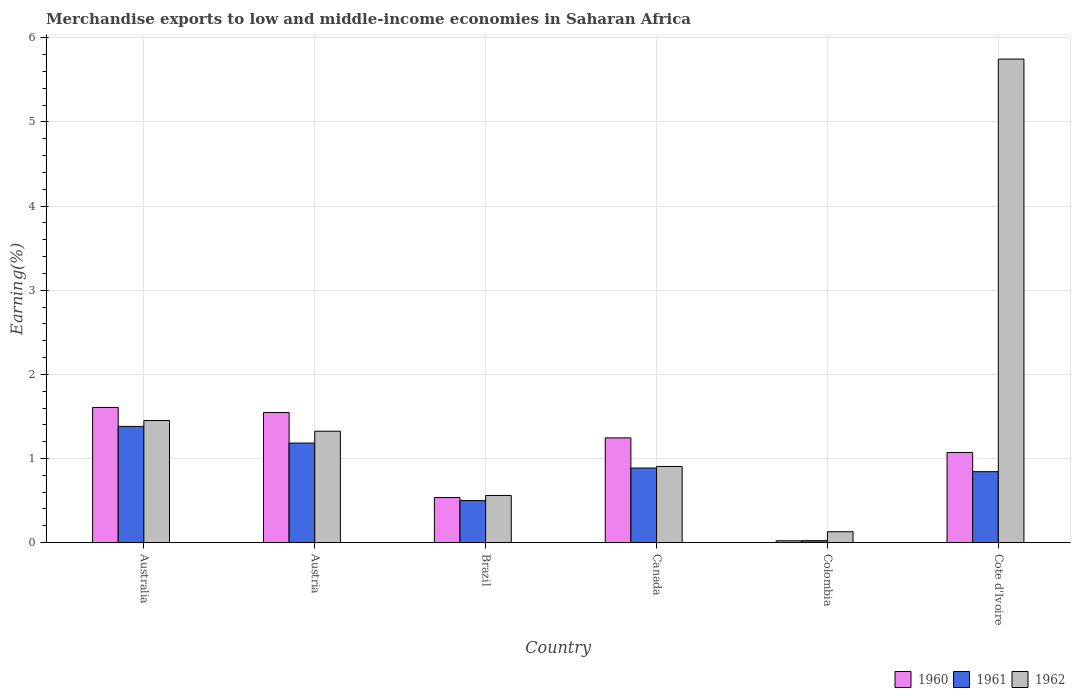How many groups of bars are there?
Give a very brief answer. 6. Are the number of bars on each tick of the X-axis equal?
Offer a terse response. Yes. How many bars are there on the 2nd tick from the left?
Ensure brevity in your answer.  3. What is the label of the 2nd group of bars from the left?
Provide a succinct answer. Austria. What is the percentage of amount earned from merchandise exports in 1961 in Austria?
Your response must be concise. 1.18. Across all countries, what is the maximum percentage of amount earned from merchandise exports in 1962?
Offer a very short reply. 5.75. Across all countries, what is the minimum percentage of amount earned from merchandise exports in 1962?
Give a very brief answer. 0.13. In which country was the percentage of amount earned from merchandise exports in 1962 maximum?
Your answer should be compact. Cote d'Ivoire. In which country was the percentage of amount earned from merchandise exports in 1962 minimum?
Your answer should be compact. Colombia. What is the total percentage of amount earned from merchandise exports in 1962 in the graph?
Your response must be concise. 10.12. What is the difference between the percentage of amount earned from merchandise exports in 1961 in Brazil and that in Colombia?
Give a very brief answer. 0.48. What is the difference between the percentage of amount earned from merchandise exports in 1960 in Canada and the percentage of amount earned from merchandise exports in 1961 in Cote d'Ivoire?
Your response must be concise. 0.4. What is the average percentage of amount earned from merchandise exports in 1961 per country?
Make the answer very short. 0.8. What is the difference between the percentage of amount earned from merchandise exports of/in 1961 and percentage of amount earned from merchandise exports of/in 1960 in Cote d'Ivoire?
Your response must be concise. -0.23. What is the ratio of the percentage of amount earned from merchandise exports in 1962 in Australia to that in Colombia?
Offer a terse response. 11.23. Is the difference between the percentage of amount earned from merchandise exports in 1961 in Australia and Cote d'Ivoire greater than the difference between the percentage of amount earned from merchandise exports in 1960 in Australia and Cote d'Ivoire?
Your answer should be compact. Yes. What is the difference between the highest and the second highest percentage of amount earned from merchandise exports in 1960?
Offer a terse response. 0.36. What is the difference between the highest and the lowest percentage of amount earned from merchandise exports in 1962?
Provide a succinct answer. 5.62. Is it the case that in every country, the sum of the percentage of amount earned from merchandise exports in 1961 and percentage of amount earned from merchandise exports in 1960 is greater than the percentage of amount earned from merchandise exports in 1962?
Your response must be concise. No. How many bars are there?
Provide a short and direct response. 18. Are all the bars in the graph horizontal?
Provide a short and direct response. No. What is the difference between two consecutive major ticks on the Y-axis?
Provide a succinct answer. 1. Does the graph contain any zero values?
Your response must be concise. No. How many legend labels are there?
Offer a terse response. 3. What is the title of the graph?
Give a very brief answer. Merchandise exports to low and middle-income economies in Saharan Africa. Does "1994" appear as one of the legend labels in the graph?
Your answer should be compact. No. What is the label or title of the X-axis?
Your answer should be very brief. Country. What is the label or title of the Y-axis?
Make the answer very short. Earning(%). What is the Earning(%) in 1960 in Australia?
Your answer should be compact. 1.61. What is the Earning(%) in 1961 in Australia?
Keep it short and to the point. 1.38. What is the Earning(%) in 1962 in Australia?
Offer a very short reply. 1.45. What is the Earning(%) in 1960 in Austria?
Your response must be concise. 1.55. What is the Earning(%) of 1961 in Austria?
Offer a terse response. 1.18. What is the Earning(%) of 1962 in Austria?
Make the answer very short. 1.32. What is the Earning(%) of 1960 in Brazil?
Provide a short and direct response. 0.54. What is the Earning(%) of 1961 in Brazil?
Offer a terse response. 0.5. What is the Earning(%) in 1962 in Brazil?
Your answer should be compact. 0.56. What is the Earning(%) of 1960 in Canada?
Provide a succinct answer. 1.24. What is the Earning(%) in 1961 in Canada?
Provide a succinct answer. 0.89. What is the Earning(%) in 1962 in Canada?
Ensure brevity in your answer.  0.9. What is the Earning(%) of 1960 in Colombia?
Your answer should be compact. 0.02. What is the Earning(%) of 1961 in Colombia?
Make the answer very short. 0.02. What is the Earning(%) in 1962 in Colombia?
Keep it short and to the point. 0.13. What is the Earning(%) in 1960 in Cote d'Ivoire?
Provide a short and direct response. 1.07. What is the Earning(%) in 1961 in Cote d'Ivoire?
Ensure brevity in your answer.  0.84. What is the Earning(%) of 1962 in Cote d'Ivoire?
Your answer should be compact. 5.75. Across all countries, what is the maximum Earning(%) in 1960?
Ensure brevity in your answer.  1.61. Across all countries, what is the maximum Earning(%) in 1961?
Provide a short and direct response. 1.38. Across all countries, what is the maximum Earning(%) of 1962?
Ensure brevity in your answer.  5.75. Across all countries, what is the minimum Earning(%) of 1960?
Your response must be concise. 0.02. Across all countries, what is the minimum Earning(%) in 1961?
Your response must be concise. 0.02. Across all countries, what is the minimum Earning(%) in 1962?
Your answer should be very brief. 0.13. What is the total Earning(%) of 1960 in the graph?
Offer a very short reply. 6.03. What is the total Earning(%) of 1961 in the graph?
Keep it short and to the point. 4.82. What is the total Earning(%) of 1962 in the graph?
Make the answer very short. 10.12. What is the difference between the Earning(%) in 1960 in Australia and that in Austria?
Provide a succinct answer. 0.06. What is the difference between the Earning(%) in 1961 in Australia and that in Austria?
Your answer should be very brief. 0.2. What is the difference between the Earning(%) of 1962 in Australia and that in Austria?
Your answer should be compact. 0.13. What is the difference between the Earning(%) of 1960 in Australia and that in Brazil?
Keep it short and to the point. 1.07. What is the difference between the Earning(%) in 1961 in Australia and that in Brazil?
Provide a succinct answer. 0.88. What is the difference between the Earning(%) in 1962 in Australia and that in Brazil?
Your answer should be compact. 0.89. What is the difference between the Earning(%) of 1960 in Australia and that in Canada?
Offer a terse response. 0.36. What is the difference between the Earning(%) in 1961 in Australia and that in Canada?
Ensure brevity in your answer.  0.49. What is the difference between the Earning(%) of 1962 in Australia and that in Canada?
Keep it short and to the point. 0.55. What is the difference between the Earning(%) of 1960 in Australia and that in Colombia?
Your answer should be very brief. 1.59. What is the difference between the Earning(%) in 1961 in Australia and that in Colombia?
Offer a very short reply. 1.36. What is the difference between the Earning(%) in 1962 in Australia and that in Colombia?
Your answer should be very brief. 1.32. What is the difference between the Earning(%) of 1960 in Australia and that in Cote d'Ivoire?
Your answer should be very brief. 0.54. What is the difference between the Earning(%) in 1961 in Australia and that in Cote d'Ivoire?
Provide a succinct answer. 0.54. What is the difference between the Earning(%) in 1962 in Australia and that in Cote d'Ivoire?
Provide a short and direct response. -4.3. What is the difference between the Earning(%) in 1960 in Austria and that in Brazil?
Provide a succinct answer. 1.01. What is the difference between the Earning(%) in 1961 in Austria and that in Brazil?
Keep it short and to the point. 0.68. What is the difference between the Earning(%) of 1962 in Austria and that in Brazil?
Offer a very short reply. 0.76. What is the difference between the Earning(%) in 1960 in Austria and that in Canada?
Offer a terse response. 0.3. What is the difference between the Earning(%) in 1961 in Austria and that in Canada?
Offer a very short reply. 0.3. What is the difference between the Earning(%) in 1962 in Austria and that in Canada?
Your answer should be compact. 0.42. What is the difference between the Earning(%) in 1960 in Austria and that in Colombia?
Ensure brevity in your answer.  1.52. What is the difference between the Earning(%) of 1961 in Austria and that in Colombia?
Give a very brief answer. 1.16. What is the difference between the Earning(%) of 1962 in Austria and that in Colombia?
Offer a very short reply. 1.19. What is the difference between the Earning(%) in 1960 in Austria and that in Cote d'Ivoire?
Offer a terse response. 0.47. What is the difference between the Earning(%) in 1961 in Austria and that in Cote d'Ivoire?
Offer a terse response. 0.34. What is the difference between the Earning(%) in 1962 in Austria and that in Cote d'Ivoire?
Your response must be concise. -4.42. What is the difference between the Earning(%) in 1960 in Brazil and that in Canada?
Your answer should be very brief. -0.71. What is the difference between the Earning(%) in 1961 in Brazil and that in Canada?
Give a very brief answer. -0.39. What is the difference between the Earning(%) in 1962 in Brazil and that in Canada?
Make the answer very short. -0.34. What is the difference between the Earning(%) of 1960 in Brazil and that in Colombia?
Ensure brevity in your answer.  0.51. What is the difference between the Earning(%) in 1961 in Brazil and that in Colombia?
Your answer should be compact. 0.48. What is the difference between the Earning(%) in 1962 in Brazil and that in Colombia?
Provide a short and direct response. 0.43. What is the difference between the Earning(%) of 1960 in Brazil and that in Cote d'Ivoire?
Your answer should be very brief. -0.54. What is the difference between the Earning(%) of 1961 in Brazil and that in Cote d'Ivoire?
Give a very brief answer. -0.34. What is the difference between the Earning(%) of 1962 in Brazil and that in Cote d'Ivoire?
Give a very brief answer. -5.19. What is the difference between the Earning(%) of 1960 in Canada and that in Colombia?
Offer a terse response. 1.22. What is the difference between the Earning(%) of 1961 in Canada and that in Colombia?
Ensure brevity in your answer.  0.86. What is the difference between the Earning(%) of 1962 in Canada and that in Colombia?
Make the answer very short. 0.78. What is the difference between the Earning(%) in 1960 in Canada and that in Cote d'Ivoire?
Provide a short and direct response. 0.17. What is the difference between the Earning(%) of 1961 in Canada and that in Cote d'Ivoire?
Provide a short and direct response. 0.04. What is the difference between the Earning(%) of 1962 in Canada and that in Cote d'Ivoire?
Offer a terse response. -4.84. What is the difference between the Earning(%) in 1960 in Colombia and that in Cote d'Ivoire?
Your answer should be compact. -1.05. What is the difference between the Earning(%) of 1961 in Colombia and that in Cote d'Ivoire?
Make the answer very short. -0.82. What is the difference between the Earning(%) in 1962 in Colombia and that in Cote d'Ivoire?
Provide a succinct answer. -5.62. What is the difference between the Earning(%) in 1960 in Australia and the Earning(%) in 1961 in Austria?
Your answer should be compact. 0.42. What is the difference between the Earning(%) of 1960 in Australia and the Earning(%) of 1962 in Austria?
Make the answer very short. 0.28. What is the difference between the Earning(%) of 1961 in Australia and the Earning(%) of 1962 in Austria?
Make the answer very short. 0.06. What is the difference between the Earning(%) of 1960 in Australia and the Earning(%) of 1961 in Brazil?
Your answer should be compact. 1.11. What is the difference between the Earning(%) in 1960 in Australia and the Earning(%) in 1962 in Brazil?
Provide a short and direct response. 1.05. What is the difference between the Earning(%) in 1961 in Australia and the Earning(%) in 1962 in Brazil?
Offer a very short reply. 0.82. What is the difference between the Earning(%) of 1960 in Australia and the Earning(%) of 1961 in Canada?
Make the answer very short. 0.72. What is the difference between the Earning(%) in 1960 in Australia and the Earning(%) in 1962 in Canada?
Your answer should be very brief. 0.7. What is the difference between the Earning(%) of 1961 in Australia and the Earning(%) of 1962 in Canada?
Give a very brief answer. 0.48. What is the difference between the Earning(%) in 1960 in Australia and the Earning(%) in 1961 in Colombia?
Your answer should be compact. 1.58. What is the difference between the Earning(%) in 1960 in Australia and the Earning(%) in 1962 in Colombia?
Make the answer very short. 1.48. What is the difference between the Earning(%) of 1961 in Australia and the Earning(%) of 1962 in Colombia?
Offer a terse response. 1.25. What is the difference between the Earning(%) in 1960 in Australia and the Earning(%) in 1961 in Cote d'Ivoire?
Offer a very short reply. 0.76. What is the difference between the Earning(%) of 1960 in Australia and the Earning(%) of 1962 in Cote d'Ivoire?
Offer a very short reply. -4.14. What is the difference between the Earning(%) of 1961 in Australia and the Earning(%) of 1962 in Cote d'Ivoire?
Ensure brevity in your answer.  -4.37. What is the difference between the Earning(%) of 1960 in Austria and the Earning(%) of 1961 in Brazil?
Ensure brevity in your answer.  1.05. What is the difference between the Earning(%) of 1960 in Austria and the Earning(%) of 1962 in Brazil?
Offer a terse response. 0.99. What is the difference between the Earning(%) of 1961 in Austria and the Earning(%) of 1962 in Brazil?
Offer a very short reply. 0.62. What is the difference between the Earning(%) of 1960 in Austria and the Earning(%) of 1961 in Canada?
Provide a succinct answer. 0.66. What is the difference between the Earning(%) of 1960 in Austria and the Earning(%) of 1962 in Canada?
Offer a very short reply. 0.64. What is the difference between the Earning(%) of 1961 in Austria and the Earning(%) of 1962 in Canada?
Your answer should be compact. 0.28. What is the difference between the Earning(%) of 1960 in Austria and the Earning(%) of 1961 in Colombia?
Your response must be concise. 1.52. What is the difference between the Earning(%) in 1960 in Austria and the Earning(%) in 1962 in Colombia?
Offer a terse response. 1.42. What is the difference between the Earning(%) of 1961 in Austria and the Earning(%) of 1962 in Colombia?
Your answer should be compact. 1.05. What is the difference between the Earning(%) in 1960 in Austria and the Earning(%) in 1961 in Cote d'Ivoire?
Provide a succinct answer. 0.7. What is the difference between the Earning(%) in 1960 in Austria and the Earning(%) in 1962 in Cote d'Ivoire?
Make the answer very short. -4.2. What is the difference between the Earning(%) of 1961 in Austria and the Earning(%) of 1962 in Cote d'Ivoire?
Your answer should be compact. -4.57. What is the difference between the Earning(%) in 1960 in Brazil and the Earning(%) in 1961 in Canada?
Give a very brief answer. -0.35. What is the difference between the Earning(%) in 1960 in Brazil and the Earning(%) in 1962 in Canada?
Provide a short and direct response. -0.37. What is the difference between the Earning(%) of 1961 in Brazil and the Earning(%) of 1962 in Canada?
Your response must be concise. -0.41. What is the difference between the Earning(%) in 1960 in Brazil and the Earning(%) in 1961 in Colombia?
Your answer should be compact. 0.51. What is the difference between the Earning(%) in 1960 in Brazil and the Earning(%) in 1962 in Colombia?
Offer a terse response. 0.41. What is the difference between the Earning(%) of 1961 in Brazil and the Earning(%) of 1962 in Colombia?
Keep it short and to the point. 0.37. What is the difference between the Earning(%) of 1960 in Brazil and the Earning(%) of 1961 in Cote d'Ivoire?
Offer a very short reply. -0.31. What is the difference between the Earning(%) of 1960 in Brazil and the Earning(%) of 1962 in Cote d'Ivoire?
Provide a short and direct response. -5.21. What is the difference between the Earning(%) of 1961 in Brazil and the Earning(%) of 1962 in Cote d'Ivoire?
Make the answer very short. -5.25. What is the difference between the Earning(%) in 1960 in Canada and the Earning(%) in 1961 in Colombia?
Your response must be concise. 1.22. What is the difference between the Earning(%) in 1960 in Canada and the Earning(%) in 1962 in Colombia?
Your answer should be compact. 1.12. What is the difference between the Earning(%) of 1961 in Canada and the Earning(%) of 1962 in Colombia?
Offer a terse response. 0.76. What is the difference between the Earning(%) of 1960 in Canada and the Earning(%) of 1961 in Cote d'Ivoire?
Keep it short and to the point. 0.4. What is the difference between the Earning(%) in 1960 in Canada and the Earning(%) in 1962 in Cote d'Ivoire?
Ensure brevity in your answer.  -4.5. What is the difference between the Earning(%) of 1961 in Canada and the Earning(%) of 1962 in Cote d'Ivoire?
Give a very brief answer. -4.86. What is the difference between the Earning(%) of 1960 in Colombia and the Earning(%) of 1961 in Cote d'Ivoire?
Make the answer very short. -0.82. What is the difference between the Earning(%) in 1960 in Colombia and the Earning(%) in 1962 in Cote d'Ivoire?
Ensure brevity in your answer.  -5.73. What is the difference between the Earning(%) of 1961 in Colombia and the Earning(%) of 1962 in Cote d'Ivoire?
Provide a succinct answer. -5.73. What is the average Earning(%) in 1960 per country?
Ensure brevity in your answer.  1. What is the average Earning(%) of 1961 per country?
Make the answer very short. 0.8. What is the average Earning(%) of 1962 per country?
Provide a succinct answer. 1.69. What is the difference between the Earning(%) of 1960 and Earning(%) of 1961 in Australia?
Ensure brevity in your answer.  0.23. What is the difference between the Earning(%) of 1960 and Earning(%) of 1962 in Australia?
Offer a terse response. 0.16. What is the difference between the Earning(%) in 1961 and Earning(%) in 1962 in Australia?
Provide a succinct answer. -0.07. What is the difference between the Earning(%) in 1960 and Earning(%) in 1961 in Austria?
Ensure brevity in your answer.  0.36. What is the difference between the Earning(%) in 1960 and Earning(%) in 1962 in Austria?
Ensure brevity in your answer.  0.22. What is the difference between the Earning(%) in 1961 and Earning(%) in 1962 in Austria?
Provide a succinct answer. -0.14. What is the difference between the Earning(%) of 1960 and Earning(%) of 1961 in Brazil?
Ensure brevity in your answer.  0.04. What is the difference between the Earning(%) in 1960 and Earning(%) in 1962 in Brazil?
Your response must be concise. -0.02. What is the difference between the Earning(%) in 1961 and Earning(%) in 1962 in Brazil?
Your response must be concise. -0.06. What is the difference between the Earning(%) in 1960 and Earning(%) in 1961 in Canada?
Provide a short and direct response. 0.36. What is the difference between the Earning(%) in 1960 and Earning(%) in 1962 in Canada?
Provide a short and direct response. 0.34. What is the difference between the Earning(%) of 1961 and Earning(%) of 1962 in Canada?
Your answer should be compact. -0.02. What is the difference between the Earning(%) in 1960 and Earning(%) in 1961 in Colombia?
Keep it short and to the point. -0. What is the difference between the Earning(%) in 1960 and Earning(%) in 1962 in Colombia?
Offer a very short reply. -0.11. What is the difference between the Earning(%) in 1961 and Earning(%) in 1962 in Colombia?
Provide a short and direct response. -0.11. What is the difference between the Earning(%) of 1960 and Earning(%) of 1961 in Cote d'Ivoire?
Your answer should be compact. 0.23. What is the difference between the Earning(%) in 1960 and Earning(%) in 1962 in Cote d'Ivoire?
Your response must be concise. -4.68. What is the difference between the Earning(%) in 1961 and Earning(%) in 1962 in Cote d'Ivoire?
Provide a succinct answer. -4.91. What is the ratio of the Earning(%) in 1960 in Australia to that in Austria?
Provide a short and direct response. 1.04. What is the ratio of the Earning(%) in 1961 in Australia to that in Austria?
Ensure brevity in your answer.  1.17. What is the ratio of the Earning(%) in 1962 in Australia to that in Austria?
Keep it short and to the point. 1.1. What is the ratio of the Earning(%) in 1960 in Australia to that in Brazil?
Your response must be concise. 3. What is the ratio of the Earning(%) in 1961 in Australia to that in Brazil?
Provide a succinct answer. 2.77. What is the ratio of the Earning(%) in 1962 in Australia to that in Brazil?
Give a very brief answer. 2.59. What is the ratio of the Earning(%) in 1960 in Australia to that in Canada?
Give a very brief answer. 1.29. What is the ratio of the Earning(%) of 1961 in Australia to that in Canada?
Make the answer very short. 1.56. What is the ratio of the Earning(%) of 1962 in Australia to that in Canada?
Make the answer very short. 1.6. What is the ratio of the Earning(%) in 1960 in Australia to that in Colombia?
Your response must be concise. 74.77. What is the ratio of the Earning(%) of 1961 in Australia to that in Colombia?
Provide a short and direct response. 60.1. What is the ratio of the Earning(%) in 1962 in Australia to that in Colombia?
Make the answer very short. 11.23. What is the ratio of the Earning(%) of 1960 in Australia to that in Cote d'Ivoire?
Your answer should be very brief. 1.5. What is the ratio of the Earning(%) of 1961 in Australia to that in Cote d'Ivoire?
Offer a terse response. 1.64. What is the ratio of the Earning(%) in 1962 in Australia to that in Cote d'Ivoire?
Ensure brevity in your answer.  0.25. What is the ratio of the Earning(%) of 1960 in Austria to that in Brazil?
Provide a succinct answer. 2.89. What is the ratio of the Earning(%) of 1961 in Austria to that in Brazil?
Keep it short and to the point. 2.37. What is the ratio of the Earning(%) in 1962 in Austria to that in Brazil?
Give a very brief answer. 2.36. What is the ratio of the Earning(%) of 1960 in Austria to that in Canada?
Ensure brevity in your answer.  1.24. What is the ratio of the Earning(%) in 1961 in Austria to that in Canada?
Your answer should be very brief. 1.33. What is the ratio of the Earning(%) of 1962 in Austria to that in Canada?
Provide a short and direct response. 1.46. What is the ratio of the Earning(%) of 1960 in Austria to that in Colombia?
Provide a succinct answer. 71.96. What is the ratio of the Earning(%) of 1961 in Austria to that in Colombia?
Provide a succinct answer. 51.49. What is the ratio of the Earning(%) in 1962 in Austria to that in Colombia?
Your answer should be compact. 10.25. What is the ratio of the Earning(%) of 1960 in Austria to that in Cote d'Ivoire?
Ensure brevity in your answer.  1.44. What is the ratio of the Earning(%) of 1961 in Austria to that in Cote d'Ivoire?
Give a very brief answer. 1.4. What is the ratio of the Earning(%) in 1962 in Austria to that in Cote d'Ivoire?
Offer a terse response. 0.23. What is the ratio of the Earning(%) of 1960 in Brazil to that in Canada?
Ensure brevity in your answer.  0.43. What is the ratio of the Earning(%) of 1961 in Brazil to that in Canada?
Your answer should be compact. 0.56. What is the ratio of the Earning(%) of 1962 in Brazil to that in Canada?
Provide a succinct answer. 0.62. What is the ratio of the Earning(%) of 1960 in Brazil to that in Colombia?
Provide a short and direct response. 24.92. What is the ratio of the Earning(%) of 1961 in Brazil to that in Colombia?
Offer a very short reply. 21.72. What is the ratio of the Earning(%) in 1962 in Brazil to that in Colombia?
Offer a terse response. 4.34. What is the ratio of the Earning(%) in 1960 in Brazil to that in Cote d'Ivoire?
Ensure brevity in your answer.  0.5. What is the ratio of the Earning(%) in 1961 in Brazil to that in Cote d'Ivoire?
Your answer should be very brief. 0.59. What is the ratio of the Earning(%) in 1962 in Brazil to that in Cote d'Ivoire?
Give a very brief answer. 0.1. What is the ratio of the Earning(%) in 1960 in Canada to that in Colombia?
Your response must be concise. 57.92. What is the ratio of the Earning(%) of 1961 in Canada to that in Colombia?
Keep it short and to the point. 38.58. What is the ratio of the Earning(%) in 1962 in Canada to that in Colombia?
Give a very brief answer. 7.01. What is the ratio of the Earning(%) of 1960 in Canada to that in Cote d'Ivoire?
Offer a very short reply. 1.16. What is the ratio of the Earning(%) of 1961 in Canada to that in Cote d'Ivoire?
Provide a short and direct response. 1.05. What is the ratio of the Earning(%) in 1962 in Canada to that in Cote d'Ivoire?
Your answer should be compact. 0.16. What is the ratio of the Earning(%) in 1960 in Colombia to that in Cote d'Ivoire?
Your answer should be compact. 0.02. What is the ratio of the Earning(%) of 1961 in Colombia to that in Cote d'Ivoire?
Provide a short and direct response. 0.03. What is the ratio of the Earning(%) of 1962 in Colombia to that in Cote d'Ivoire?
Offer a terse response. 0.02. What is the difference between the highest and the second highest Earning(%) in 1960?
Give a very brief answer. 0.06. What is the difference between the highest and the second highest Earning(%) in 1961?
Offer a terse response. 0.2. What is the difference between the highest and the second highest Earning(%) of 1962?
Your answer should be compact. 4.3. What is the difference between the highest and the lowest Earning(%) of 1960?
Provide a short and direct response. 1.59. What is the difference between the highest and the lowest Earning(%) in 1961?
Provide a short and direct response. 1.36. What is the difference between the highest and the lowest Earning(%) of 1962?
Give a very brief answer. 5.62. 